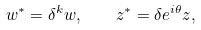Convert formula to latex. <formula><loc_0><loc_0><loc_500><loc_500>w ^ { * } = \delta ^ { k } w , \quad z ^ { * } = \delta e ^ { i \theta } z , \</formula> 